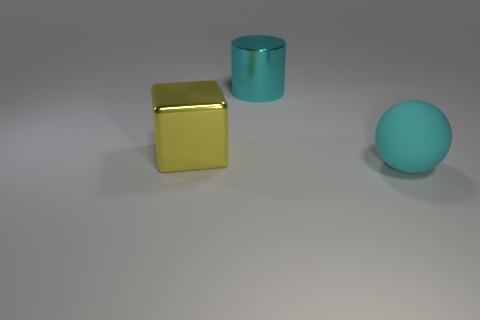Add 1 yellow things. How many objects exist? 4 Subtract all cylinders. How many objects are left? 2 Subtract 1 balls. How many balls are left? 0 Add 3 big cyan rubber things. How many big cyan rubber things are left? 4 Add 3 large cyan cylinders. How many large cyan cylinders exist? 4 Subtract 0 green balls. How many objects are left? 3 Subtract all yellow balls. Subtract all blue cubes. How many balls are left? 1 Subtract all tiny metallic spheres. Subtract all big cylinders. How many objects are left? 2 